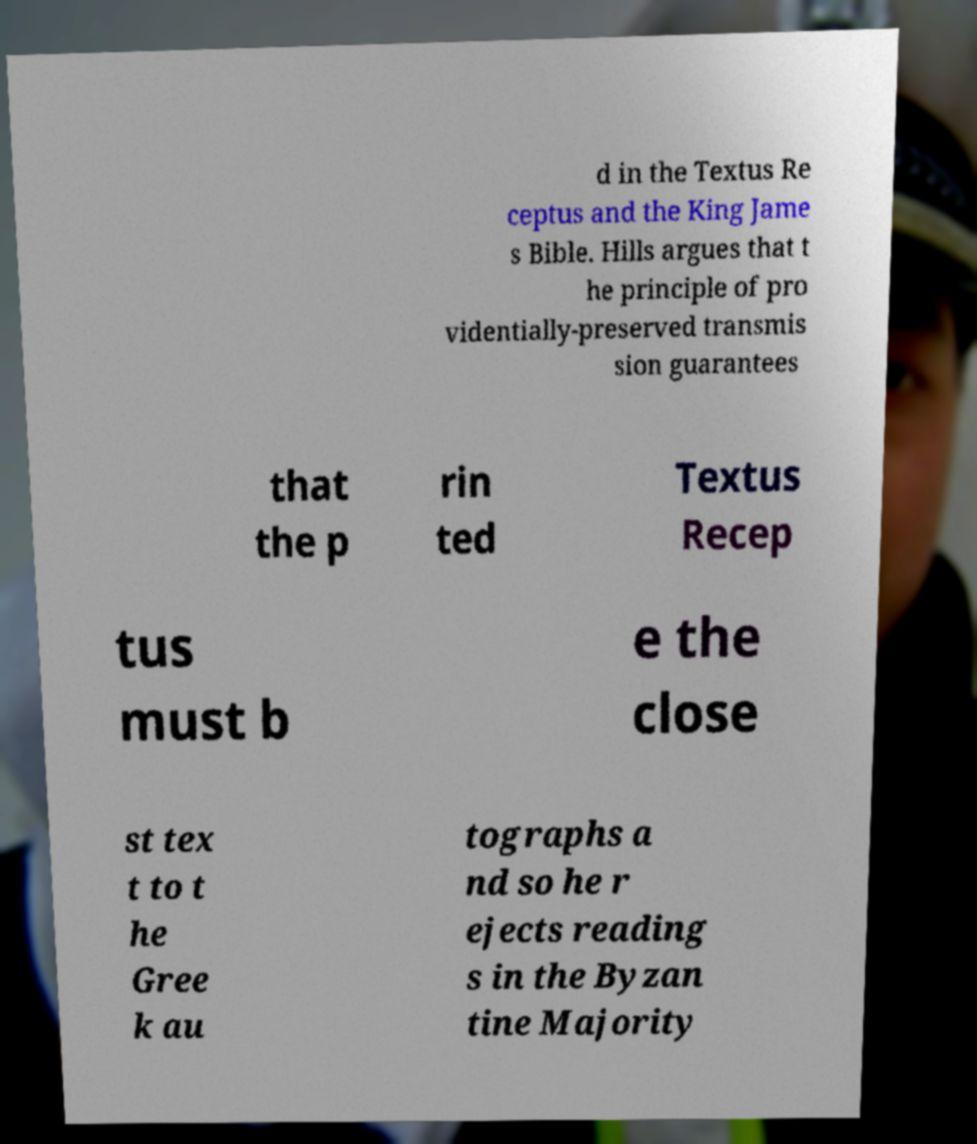Please identify and transcribe the text found in this image. d in the Textus Re ceptus and the King Jame s Bible. Hills argues that t he principle of pro videntially-preserved transmis sion guarantees that the p rin ted Textus Recep tus must b e the close st tex t to t he Gree k au tographs a nd so he r ejects reading s in the Byzan tine Majority 